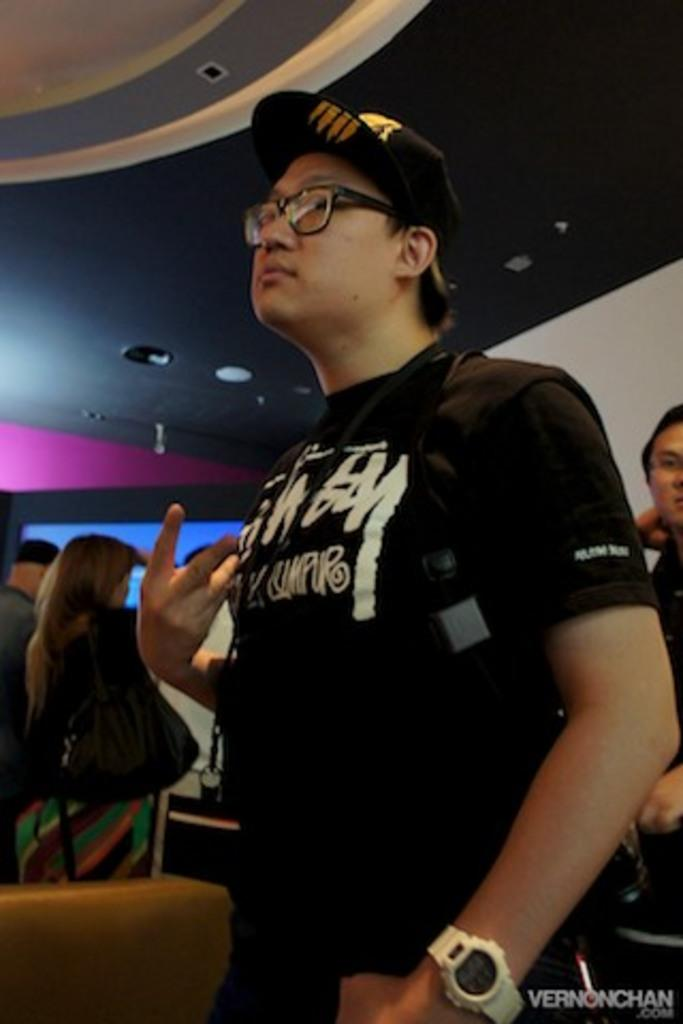What is the main subject of the image? The main subject of the image is a group of people standing. What can be seen above the people in the image? There is a ceiling visible at the top of the image. Is there any additional information or marking on the image? Yes, there is a watermark at the bottom right side of the image. What type of ink is used for the fifth theory in the image? There is no reference to any theories or ink in the image; it simply shows a group of people standing with a visible ceiling. 